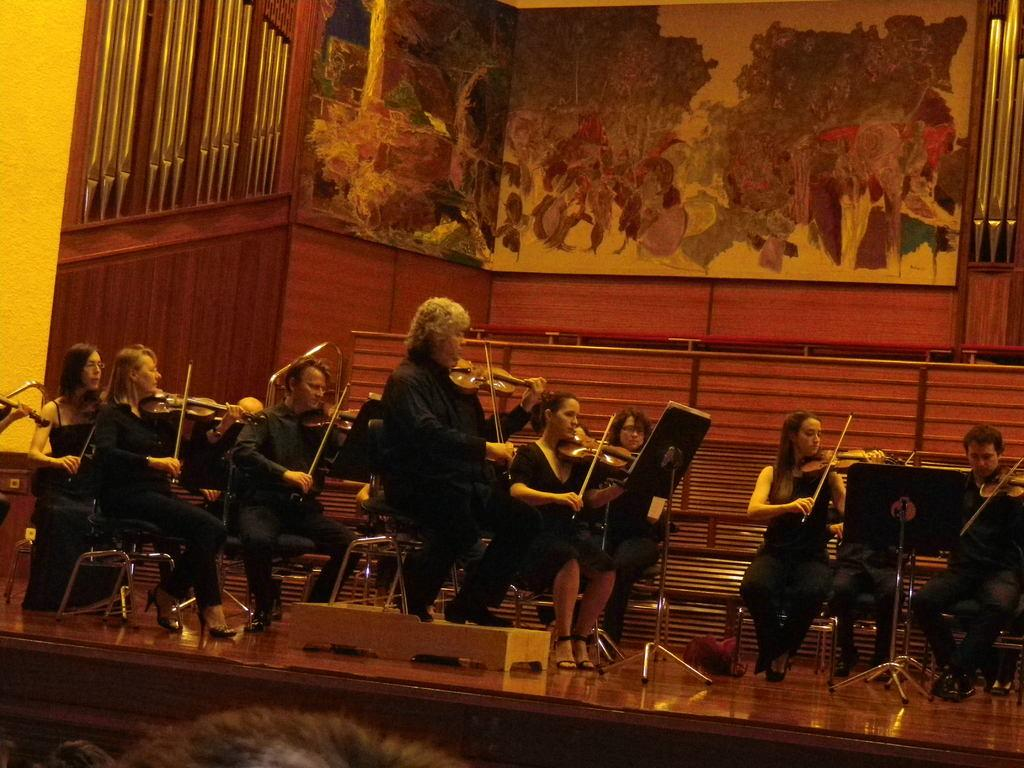What is happening in the image involving a group of people? There is a group of people in the image, and they are playing a violin. Where are the people sitting in the image? The people are sitting on chairs in the image. What is the setting of the scene? The scene takes place on a stage. What can be seen behind the people on the stage? There is a wall behind the people, and it contains a painting. What type of flesh can be seen in the image? There is no flesh visible in the image; it features a group of people playing violins on a stage. How many bushes are present in the image? There are no bushes present in the image; it takes place on a stage with a wall and a painting. 